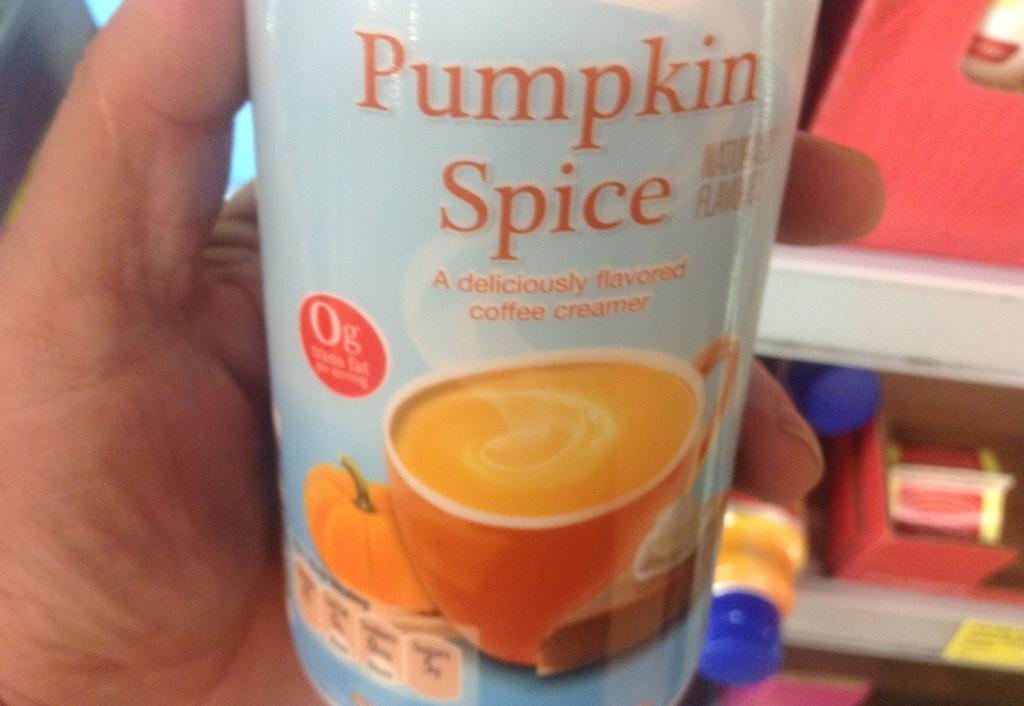What is the main subject in the foreground of the image? There is a person in the foreground of the image. What is the person holding in the image? The person is holding a container. What can be seen in the background of the image? There is a bottle, a box, and other objects in the background of the image. What type of crayon is the person using to draw on the box in the image? There is no crayon or drawing activity present in the image. 